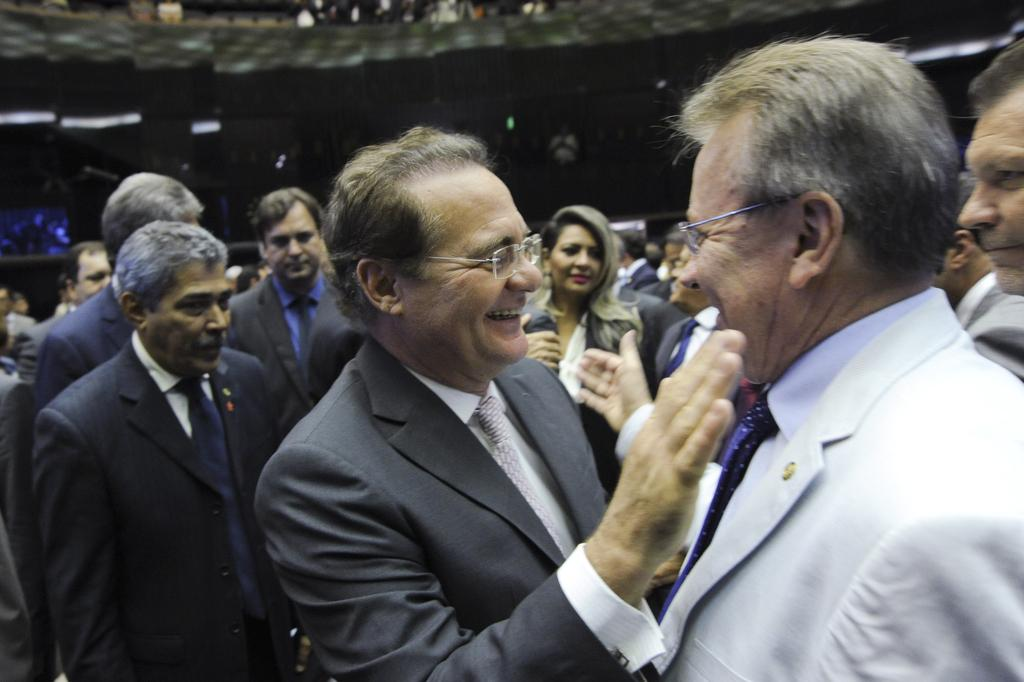What is the main subject of the image? The main subject of the image is a group of people. Can you describe the facial expression of one of the people in the image? One person in the image is smiling. How would you describe the background of the image? The background has a blurred view. What type of ring can be seen on the finger of the person in the image? There is no ring visible on any person's finger in the image. What arithmetic problem is being solved by the group of people in the image? There is no indication in the image that the group of people is solving an arithmetic problem. 